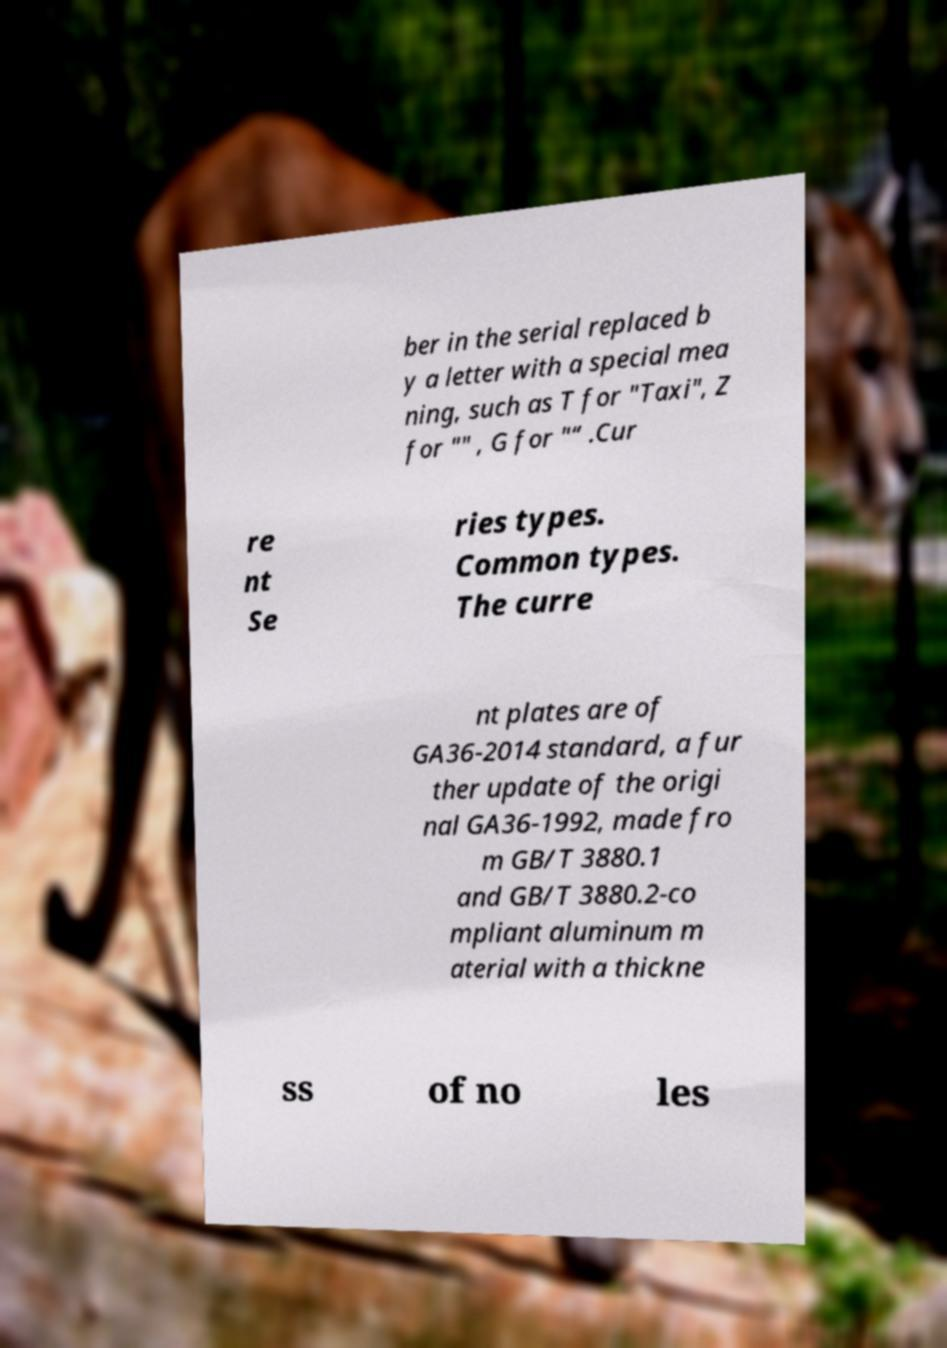Can you accurately transcribe the text from the provided image for me? ber in the serial replaced b y a letter with a special mea ning, such as T for "Taxi", Z for "" , G for "“ .Cur re nt Se ries types. Common types. The curre nt plates are of GA36-2014 standard, a fur ther update of the origi nal GA36-1992, made fro m GB/T 3880.1 and GB/T 3880.2-co mpliant aluminum m aterial with a thickne ss of no les 